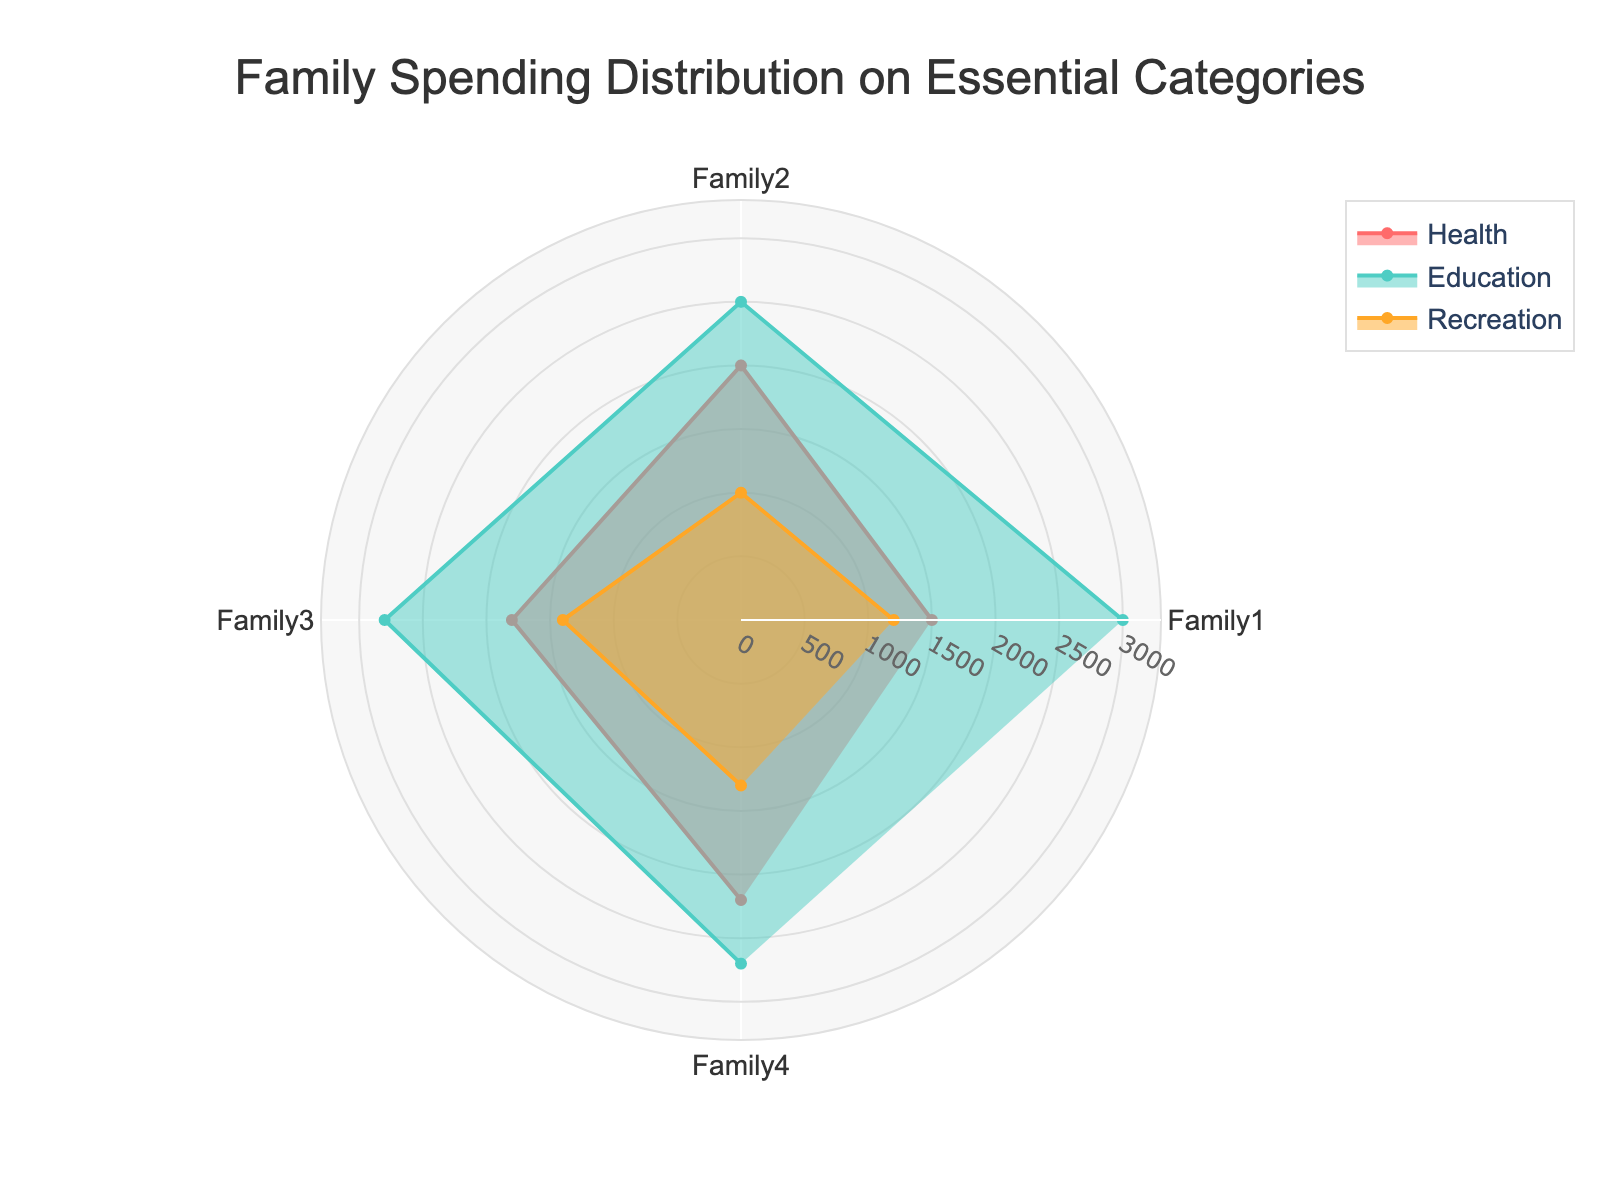Which category has the highest value for Family4? By observing the radar chart, you can see the three lines representing Health, Education, and Recreation for Family4. The Education trace reaches the highest radial distance.
Answer: Education What is the total spending for Family1 across all categories? Identify and sum the individual values for Health, Education, and Recreation for Family1 from the radar chart or data table. The values are 1500, 3000, and 1200 respectively, giving a total of 1500 + 3000 + 1200 = 5700.
Answer: 5700 Which family spends the least on Recreation? Compare the radial distance of the Recreation line for all families. Family2’s Recreation trace is the smallest among all.
Answer: Family2 How does the spending on Health for Family3 compare to Family2? Check the radial distances of Health for both Family3 and Family2. Family2's Health spending is 2000, and Family3's Health spending is 1800. 1800 is less than 2000.
Answer: Less What is the average spending on Education across all families? Sum the Education spending for all families (3000, 2500, 2800, and 2700) and divide by the number of families. (3000 + 2500 + 2800 + 2700) / 4 = 2750.
Answer: 2750 Which category shows the most variance in spending among the families? Visually assess the spread of values for each category by checking their radial distance variations. Recreation appears to have the least variance, while Education shows wider spread differences.
Answer: Education What's the maximum value for Health spending among all families? Identify and compare the radial distances of the Health spending lines for all families to find the maximum value. The highest radial line for Health is Family4 with 2200.
Answer: 2200 Rank the spending in Health by each family from highest to lowest. Compare the radial distances for Health: Family4 (2200), Family2 (2000), Family3 (1800), Family1 (1500). The ranking is Family4 > Family2 > Family3 > Family1.
Answer: Family4, Family2, Family3, Family1 Which family has the most balanced spending across all categories? Look for the family whose radar shape is the most equilateral or uniform in terms of radial distances. Family4 shows the most balanced distribution visually.
Answer: Family4 